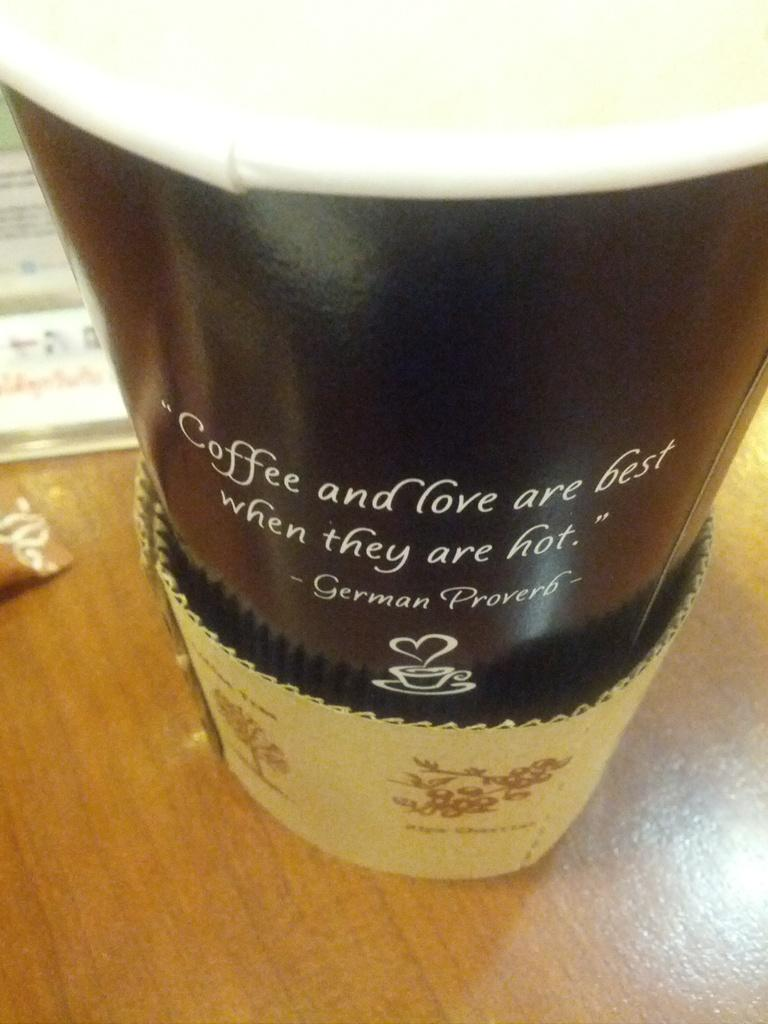<image>
Present a compact description of the photo's key features. A German Proverb is printed on the side of a disposable coffee cup. 